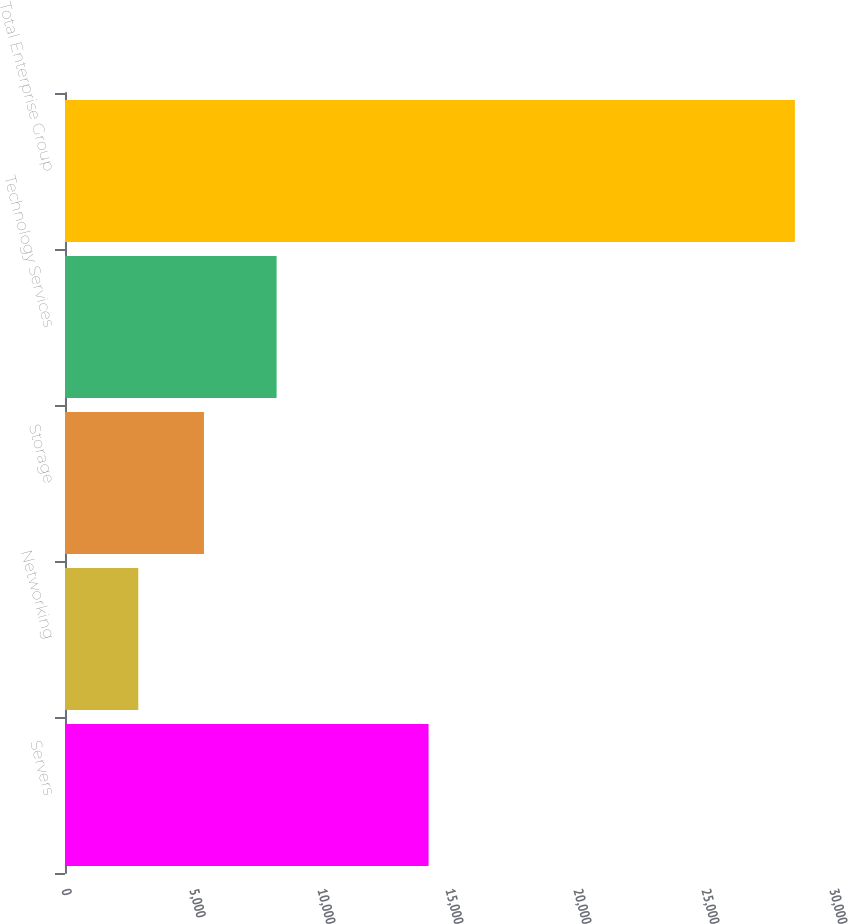<chart> <loc_0><loc_0><loc_500><loc_500><bar_chart><fcel>Servers<fcel>Networking<fcel>Storage<fcel>Technology Services<fcel>Total Enterprise Group<nl><fcel>14202<fcel>2863<fcel>5427.8<fcel>8266<fcel>28511<nl></chart> 